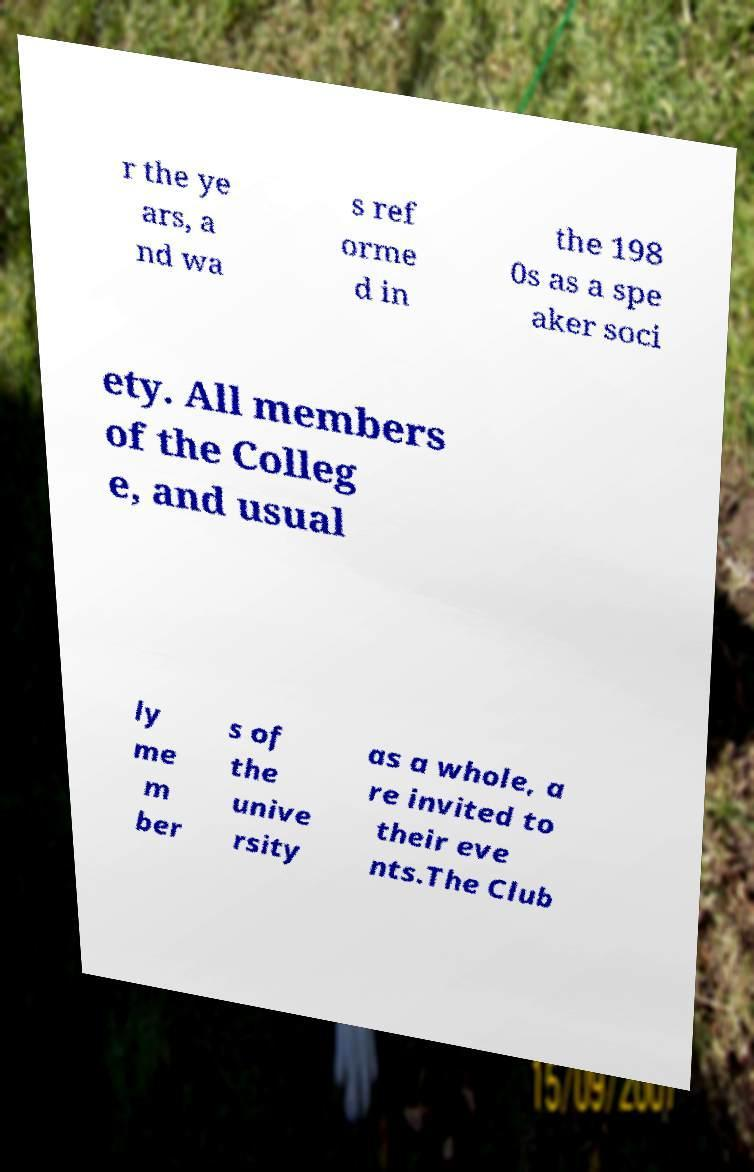There's text embedded in this image that I need extracted. Can you transcribe it verbatim? r the ye ars, a nd wa s ref orme d in the 198 0s as a spe aker soci ety. All members of the Colleg e, and usual ly me m ber s of the unive rsity as a whole, a re invited to their eve nts.The Club 